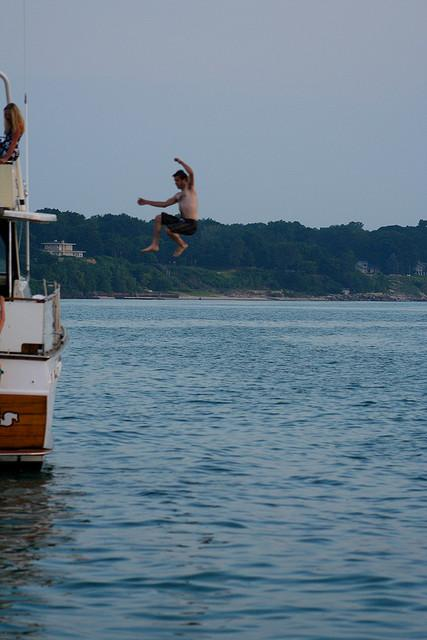Where does the man want to go?

Choices:
A) in raft
B) in water
C) on land
D) on boat in water 